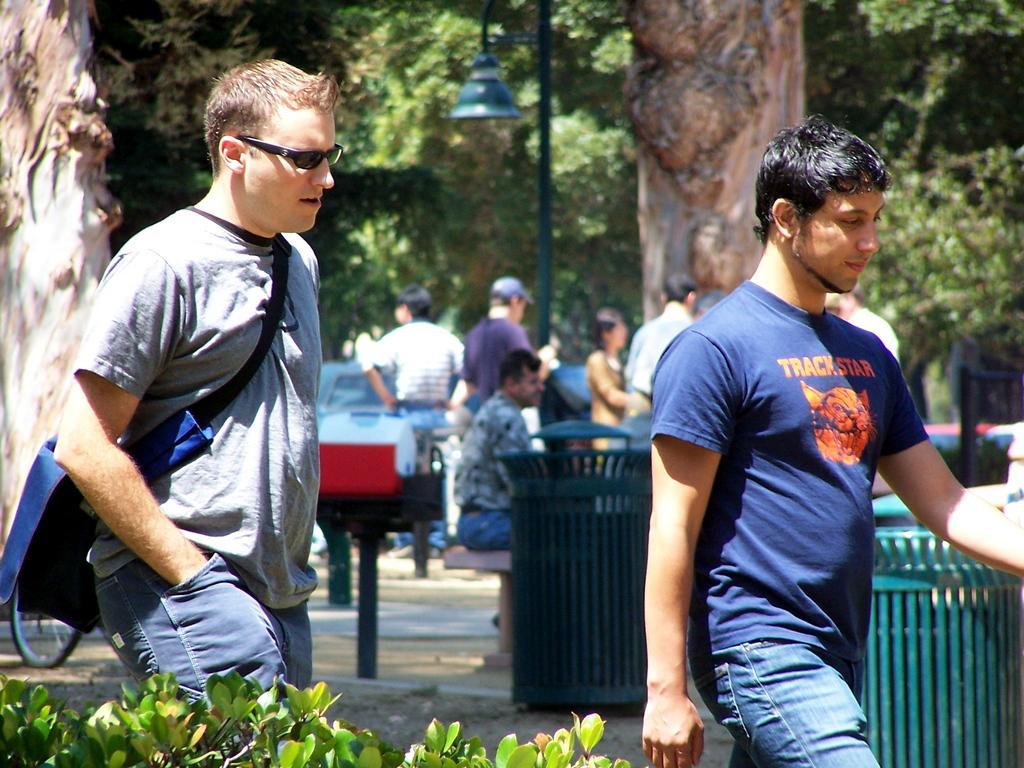In one or two sentences, can you explain what this image depicts? In this image we can see a few people, there are some trees, plants, poles, fence, light and a vehicle. 